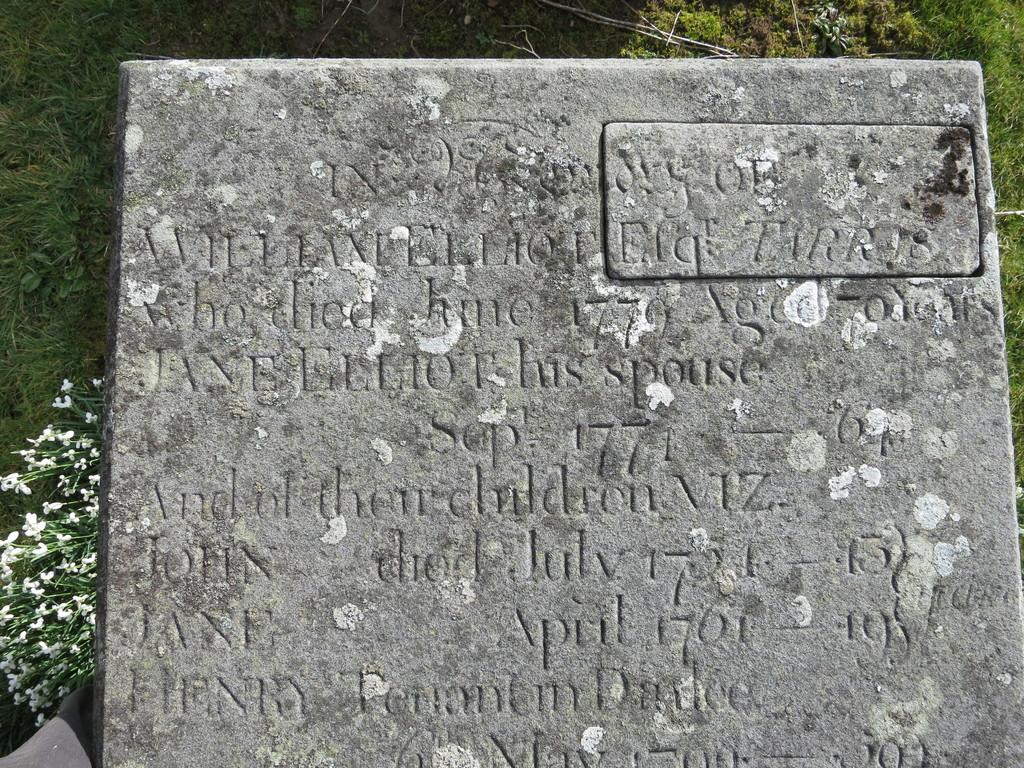What is the main object in the image? There is a headstone in the image. What is engraved or carved on the headstone? Something is carved on the headstone. What can be seen behind the headstone? There are flowers and trees behind the headstone. What type of songs can be heard playing from the paper in the image? There is no paper or songs present in the image; it features a headstone with flowers and trees in the background. 